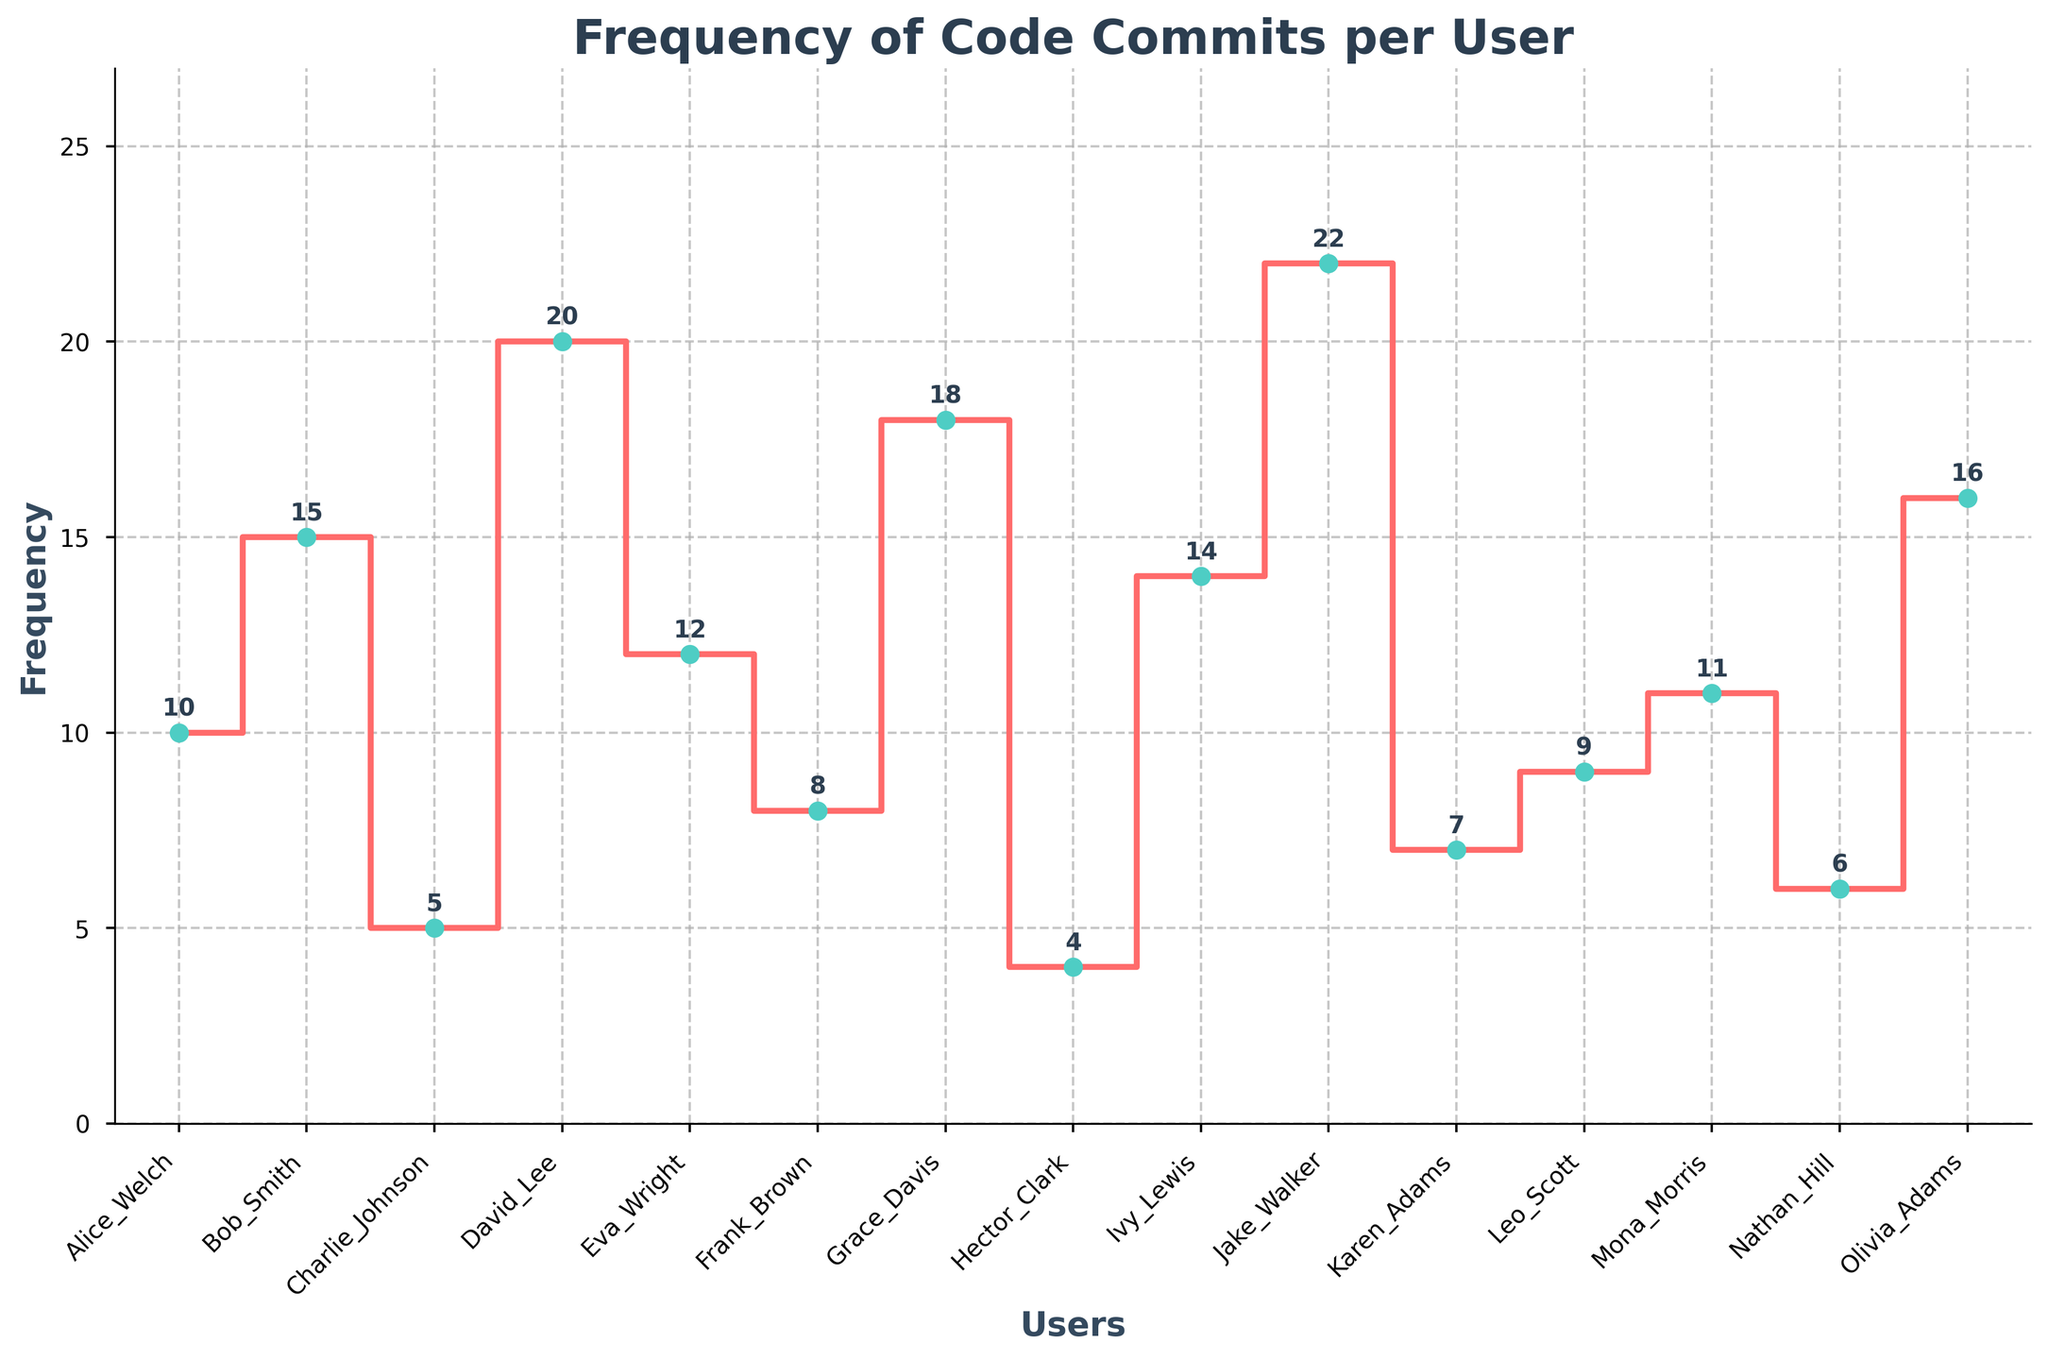What is the title of the plot? The title of the plot is displayed at the top and is often styled in bold to stand out.
Answer: Frequency of Code Commits per User What is the frequency value for David_Lee? Locate the point marked for David_Lee and refer to the annotated number on the plot.
Answer: 20 How many users have a frequency greater than 10? Count the number of users whose frequency values annotated on the plot are above 10.
Answer: 7 What is the range of frequencies shown on the plot? The range is calculated by subtracting the minimum frequency value from the maximum frequency value displayed on the plot.
Answer: 22 - 4 Which user has the highest frequency, and what is that frequency? Identify the user with the highest annotated frequency value on the plot.
Answer: Jake_Walker, 22 How does the frequency of Eva_Wright compare to that of Charlie_Johnson? Compare the annotated frequency values of Eva_Wright and Charlie_Johnson on the plot.
Answer: Eva_Wright’s frequency (12) is greater than Charlie_Johnson’s frequency (5) What is the total frequency of code commits for all users? Sum the frequency values annotated on the plot for all users: 10 + 15 + 5 + 20 + 12 + 8 + 18 + 4 + 14 + 22 + 7 + 9 + 11 + 6 + 16 = 177.
Answer: 177 What is the average frequency of code commits per user? The average is calculated by dividing the total frequency by the number of users: 177 / 15.
Answer: 11.8 Which user has the lowest frequency, and what is that frequency? Identify the user with the lowest annotated frequency value on the plot.
Answer: Hector_Clark, 4 What is the frequency difference between Bob_Smith and Frank_Brown? Subtract the frequency of Frank_Brown from the frequency of Bob_Smith: 15 - 8 = 7.
Answer: 7 